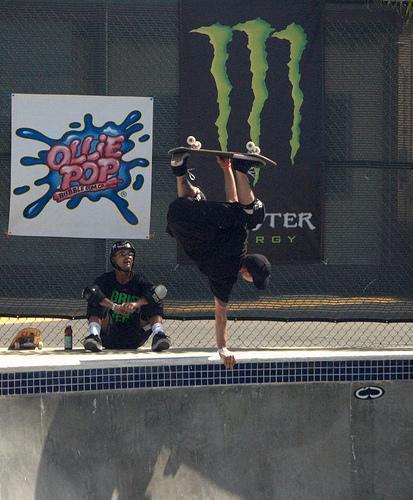What is the narcotic made popular by the poster on the wall?
Make your selection from the four choices given to correctly answer the question.
Options: Marijuana, caffeine, cocaine, meth. Caffeine. 